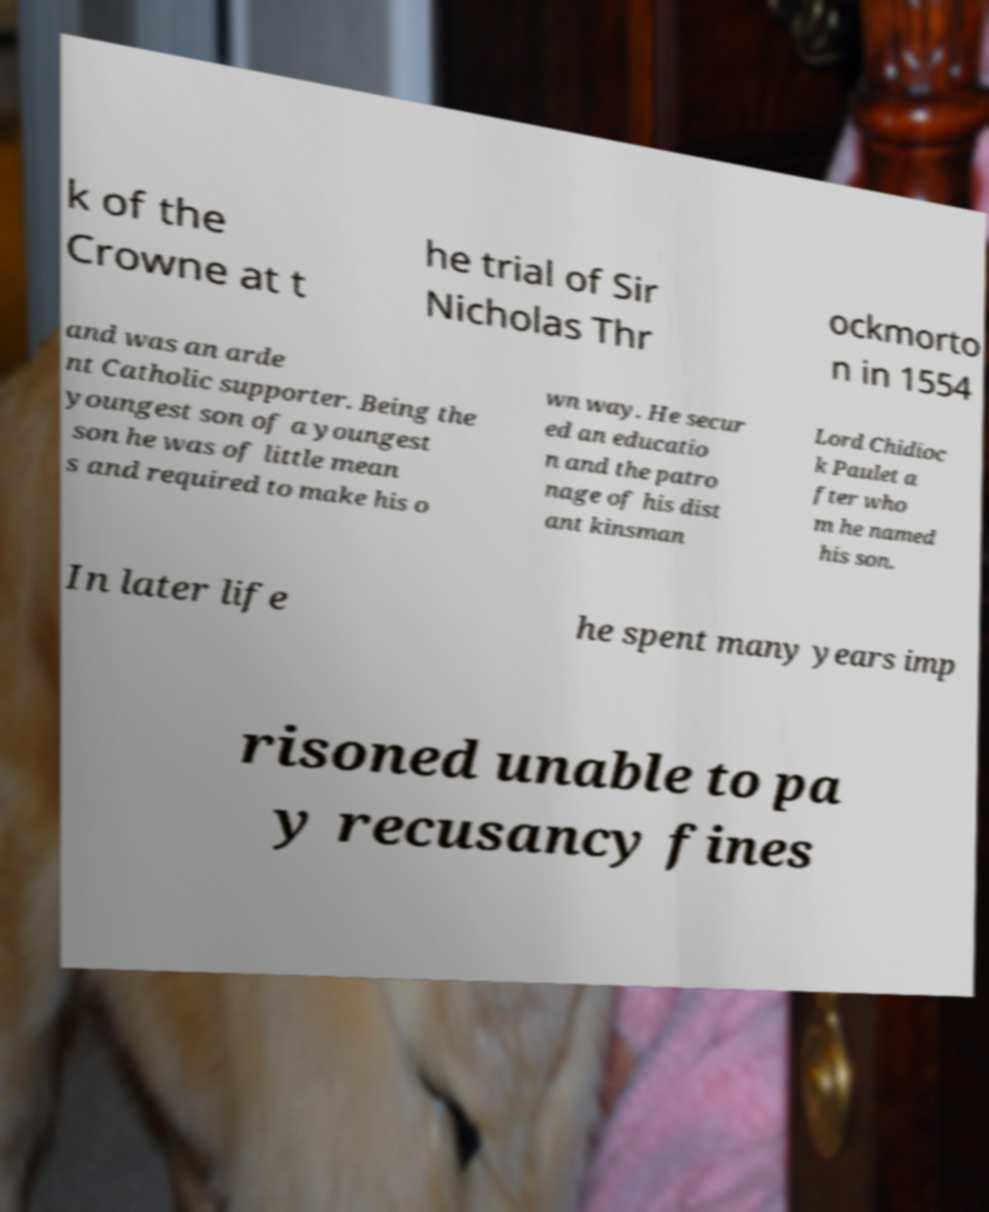Can you read and provide the text displayed in the image?This photo seems to have some interesting text. Can you extract and type it out for me? k of the Crowne at t he trial of Sir Nicholas Thr ockmorto n in 1554 and was an arde nt Catholic supporter. Being the youngest son of a youngest son he was of little mean s and required to make his o wn way. He secur ed an educatio n and the patro nage of his dist ant kinsman Lord Chidioc k Paulet a fter who m he named his son. In later life he spent many years imp risoned unable to pa y recusancy fines 